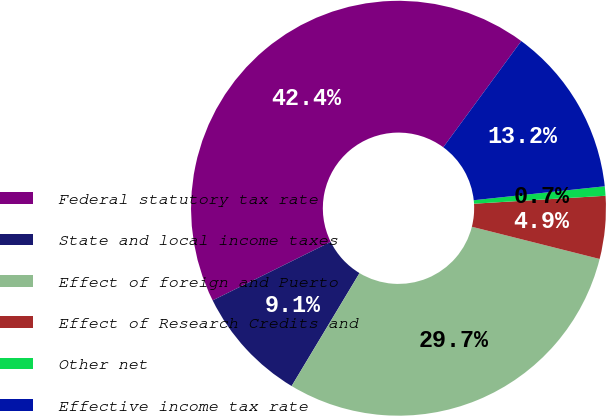Convert chart. <chart><loc_0><loc_0><loc_500><loc_500><pie_chart><fcel>Federal statutory tax rate<fcel>State and local income taxes<fcel>Effect of foreign and Puerto<fcel>Effect of Research Credits and<fcel>Other net<fcel>Effective income tax rate<nl><fcel>42.4%<fcel>9.06%<fcel>29.68%<fcel>4.89%<fcel>0.73%<fcel>13.23%<nl></chart> 